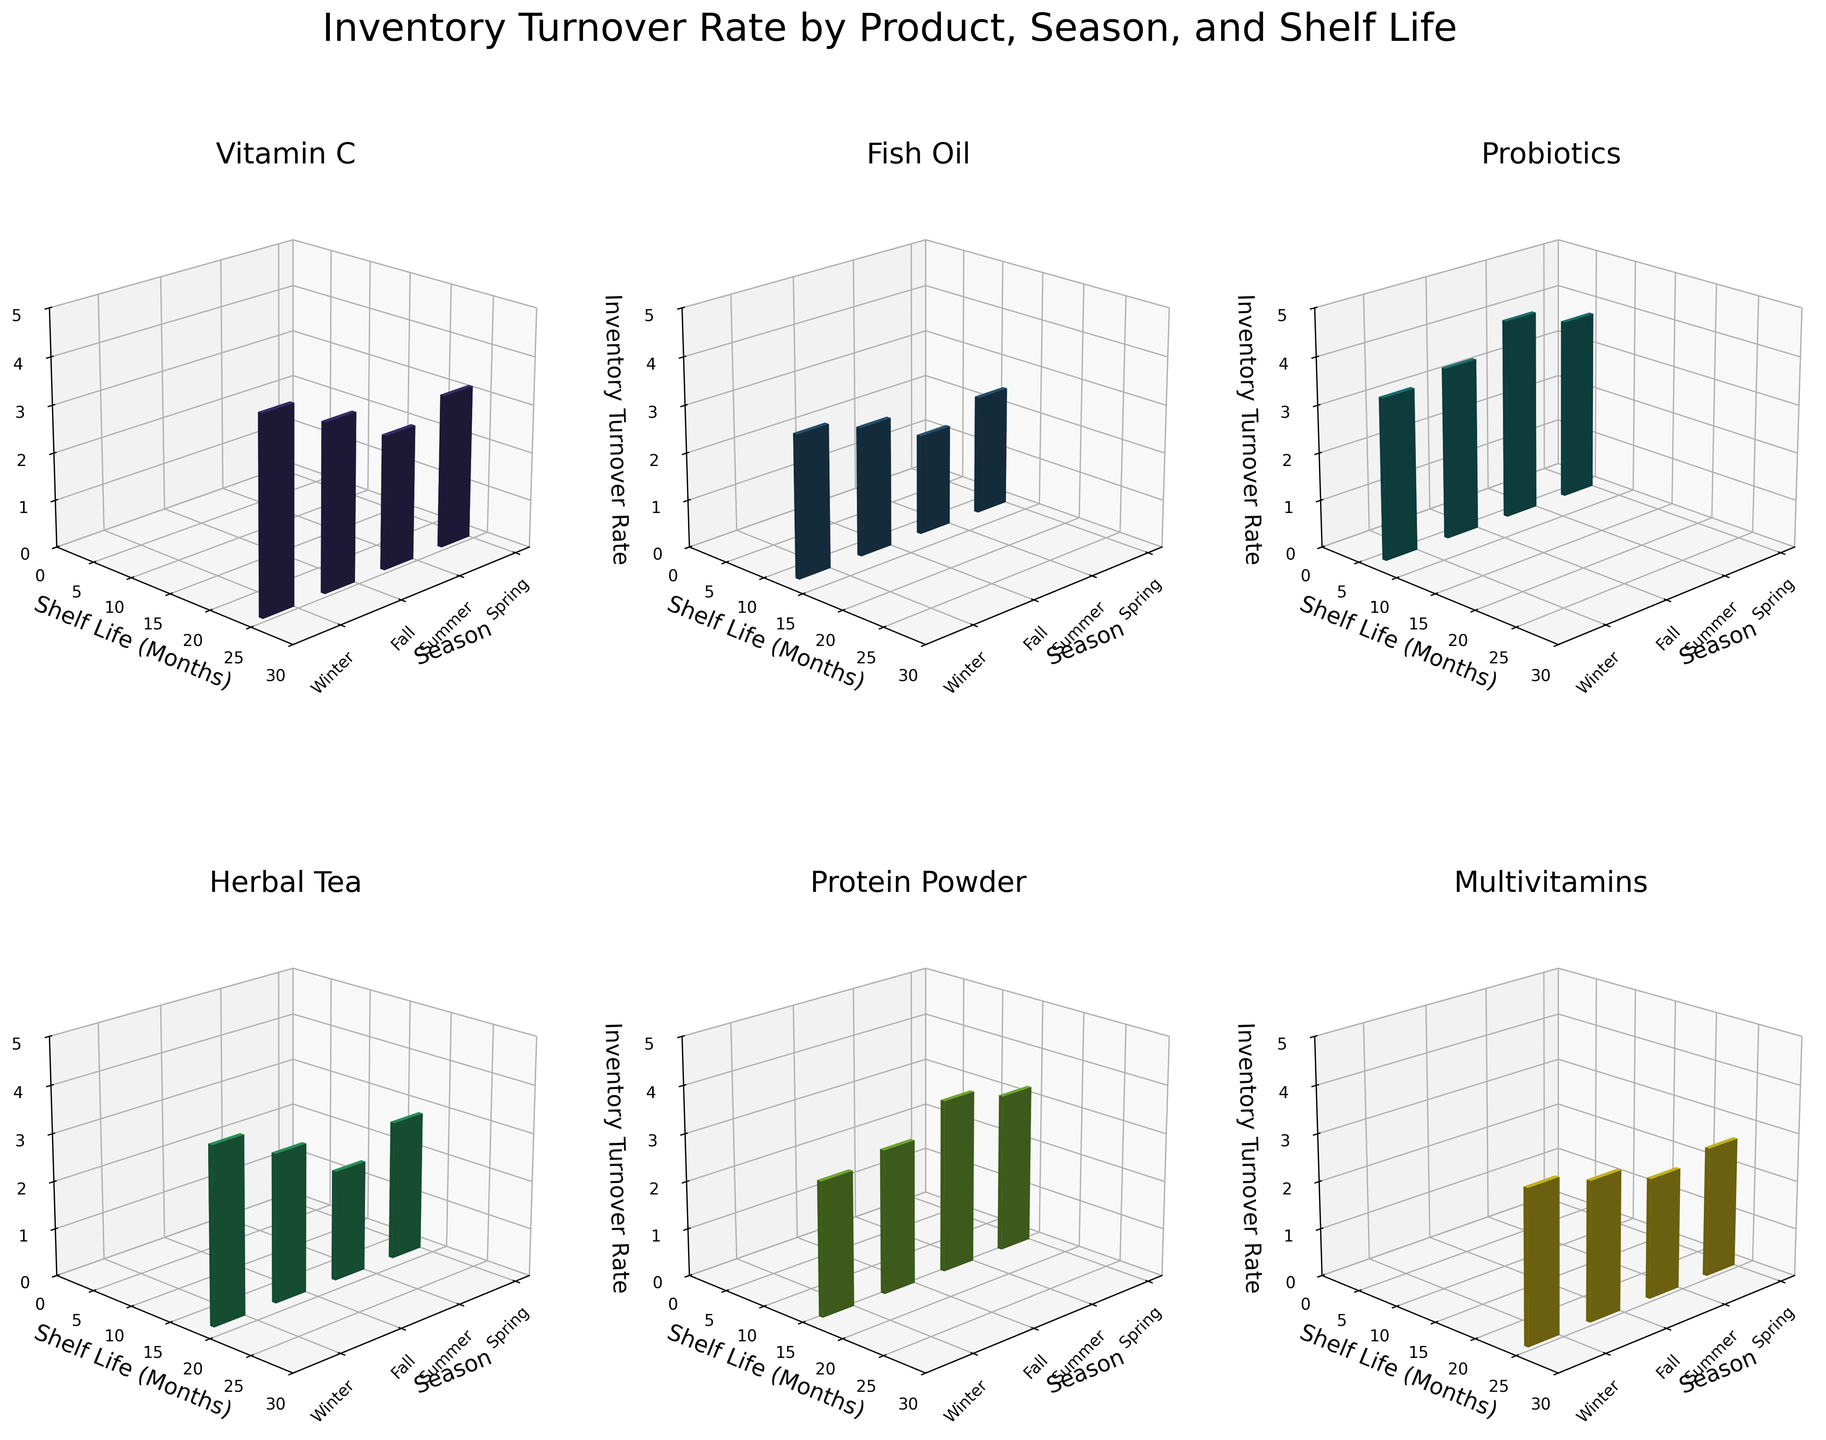What is the title of the figure? The title is located at the top center of the figure and reads "Inventory Turnover Rate by Product, Season, and Shelf Life".
Answer: Inventory Turnover Rate by Product, Season, and Shelf Life What is the shelf life of Fish Oil shown in the figure? By looking at the y-axis of the subplot titled "Fish Oil", we can see that the shelf life is constant and the labels indicate 12 months.
Answer: 12 months Which product has the highest inventory turnover rate in Winter? In the subplot for each product, we can observe the height of bars in the winter season. "Vitamin C" has the highest bar in winter reaching up to 4.1.
Answer: Vitamin C Among Protein Powder and Herbal Tea, which one has a higher average turnover rate across all seasons? To find the average, calculate the sum of the turnover rates for each season and divide by 4. For Protein Powder: (3.3 + 3.6 + 3.0 + 2.8) / 4 = 3.175. For Herbal Tea: (2.9 + 2.3 + 3.1 + 3.7) / 4 = 3.0.
Answer: Protein Powder Which product experiences the lowest inventory turnover rate during Summer? By comparing the bars for the Summer season in each subplot, Fish Oil has the lowest turnover rate at 2.1.
Answer: Fish Oil Are there any products for which the inventory turnover rate decreases as the shelf life decreases? Analyzing the subplots, especially Probiotics with a shelf life of 6 months, the turnover rate decreases from Spring (3.8) to Winter (3.4). This indicates a decrease in inventory turnover rate.
Answer: Yes How does the shelf life impact the inventory turnover rate for Multivitamins across different seasons? The subplot for Multivitamins shows the same 24 months shelf life for all seasons. Hence, the shelf life does not vary and does not impact the turnover rate seasonally.
Answer: Shelf life is constant What is the pattern of inventory turnover rate for Vitamin C across seasons? Observing the subplot for Vitamin C, the turnover rate increases from Summer (2.8) to Fall (3.5) then rises in Winter (4.1) before lowering in Spring (3.2).
Answer: Increases then decreases For which product does the inventory turnover rate show the most significant seasonal variation? By comparing the variation in each subplot, Probiotics show significant seasonal changes, with rates varying from 4.2 in Summer to 3.4 in Winter.
Answer: Probiotics 